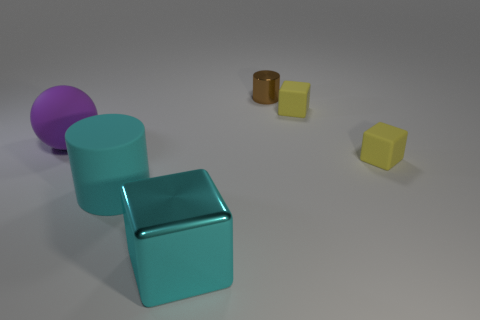Add 1 purple objects. How many objects exist? 7 Subtract all balls. How many objects are left? 5 Subtract all large brown shiny objects. Subtract all large cyan objects. How many objects are left? 4 Add 3 big cyan rubber cylinders. How many big cyan rubber cylinders are left? 4 Add 3 cyan blocks. How many cyan blocks exist? 4 Subtract 0 red cylinders. How many objects are left? 6 